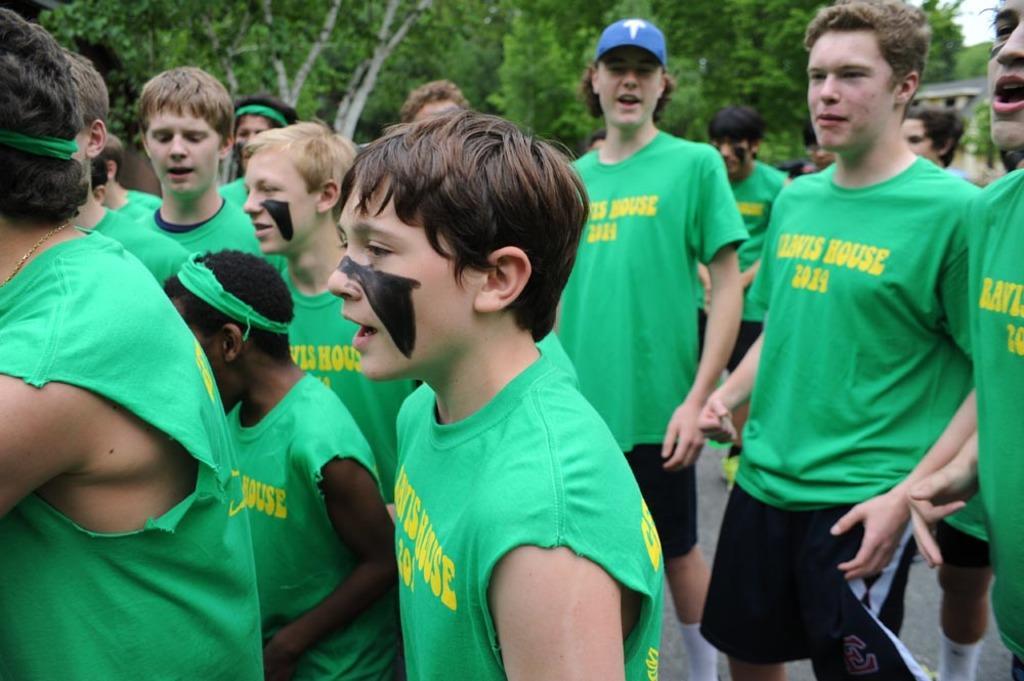In one or two sentences, can you explain what this image depicts? In this image, we can see many people and in the background, there are trees. 